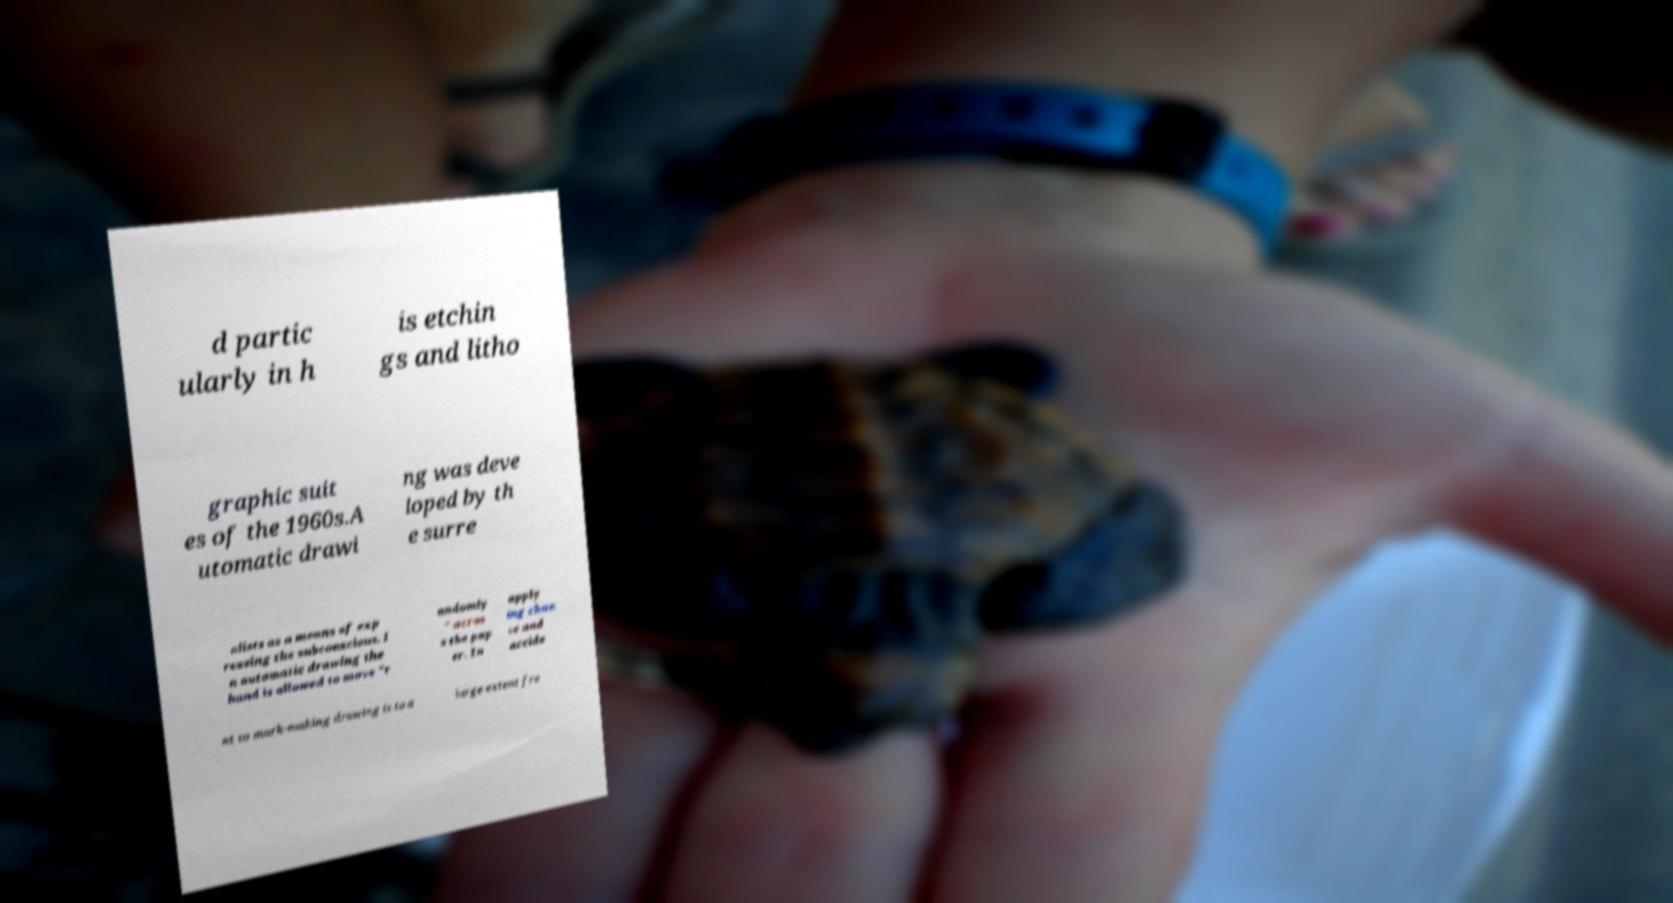I need the written content from this picture converted into text. Can you do that? d partic ularly in h is etchin gs and litho graphic suit es of the 1960s.A utomatic drawi ng was deve loped by th e surre alists as a means of exp ressing the subconscious. I n automatic drawing the hand is allowed to move "r andomly " acros s the pap er. In apply ing chan ce and accide nt to mark-making drawing is to a large extent fre 